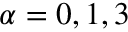<formula> <loc_0><loc_0><loc_500><loc_500>\alpha = 0 , 1 , 3</formula> 